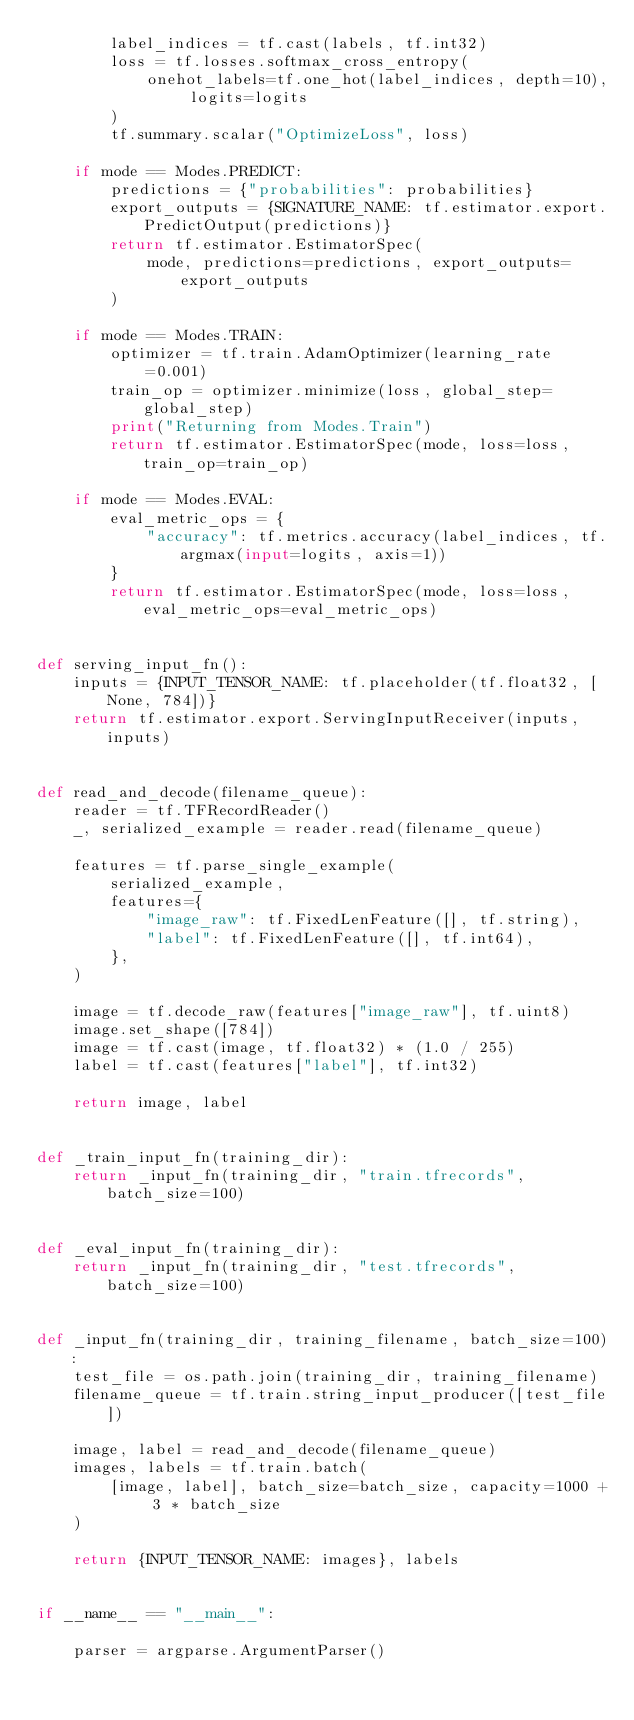Convert code to text. <code><loc_0><loc_0><loc_500><loc_500><_Python_>        label_indices = tf.cast(labels, tf.int32)
        loss = tf.losses.softmax_cross_entropy(
            onehot_labels=tf.one_hot(label_indices, depth=10), logits=logits
        )
        tf.summary.scalar("OptimizeLoss", loss)

    if mode == Modes.PREDICT:
        predictions = {"probabilities": probabilities}
        export_outputs = {SIGNATURE_NAME: tf.estimator.export.PredictOutput(predictions)}
        return tf.estimator.EstimatorSpec(
            mode, predictions=predictions, export_outputs=export_outputs
        )

    if mode == Modes.TRAIN:
        optimizer = tf.train.AdamOptimizer(learning_rate=0.001)
        train_op = optimizer.minimize(loss, global_step=global_step)
        print("Returning from Modes.Train")
        return tf.estimator.EstimatorSpec(mode, loss=loss, train_op=train_op)

    if mode == Modes.EVAL:
        eval_metric_ops = {
            "accuracy": tf.metrics.accuracy(label_indices, tf.argmax(input=logits, axis=1))
        }
        return tf.estimator.EstimatorSpec(mode, loss=loss, eval_metric_ops=eval_metric_ops)


def serving_input_fn():
    inputs = {INPUT_TENSOR_NAME: tf.placeholder(tf.float32, [None, 784])}
    return tf.estimator.export.ServingInputReceiver(inputs, inputs)


def read_and_decode(filename_queue):
    reader = tf.TFRecordReader()
    _, serialized_example = reader.read(filename_queue)

    features = tf.parse_single_example(
        serialized_example,
        features={
            "image_raw": tf.FixedLenFeature([], tf.string),
            "label": tf.FixedLenFeature([], tf.int64),
        },
    )

    image = tf.decode_raw(features["image_raw"], tf.uint8)
    image.set_shape([784])
    image = tf.cast(image, tf.float32) * (1.0 / 255)
    label = tf.cast(features["label"], tf.int32)

    return image, label


def _train_input_fn(training_dir):
    return _input_fn(training_dir, "train.tfrecords", batch_size=100)


def _eval_input_fn(training_dir):
    return _input_fn(training_dir, "test.tfrecords", batch_size=100)


def _input_fn(training_dir, training_filename, batch_size=100):
    test_file = os.path.join(training_dir, training_filename)
    filename_queue = tf.train.string_input_producer([test_file])

    image, label = read_and_decode(filename_queue)
    images, labels = tf.train.batch(
        [image, label], batch_size=batch_size, capacity=1000 + 3 * batch_size
    )

    return {INPUT_TENSOR_NAME: images}, labels


if __name__ == "__main__":

    parser = argparse.ArgumentParser()
</code> 